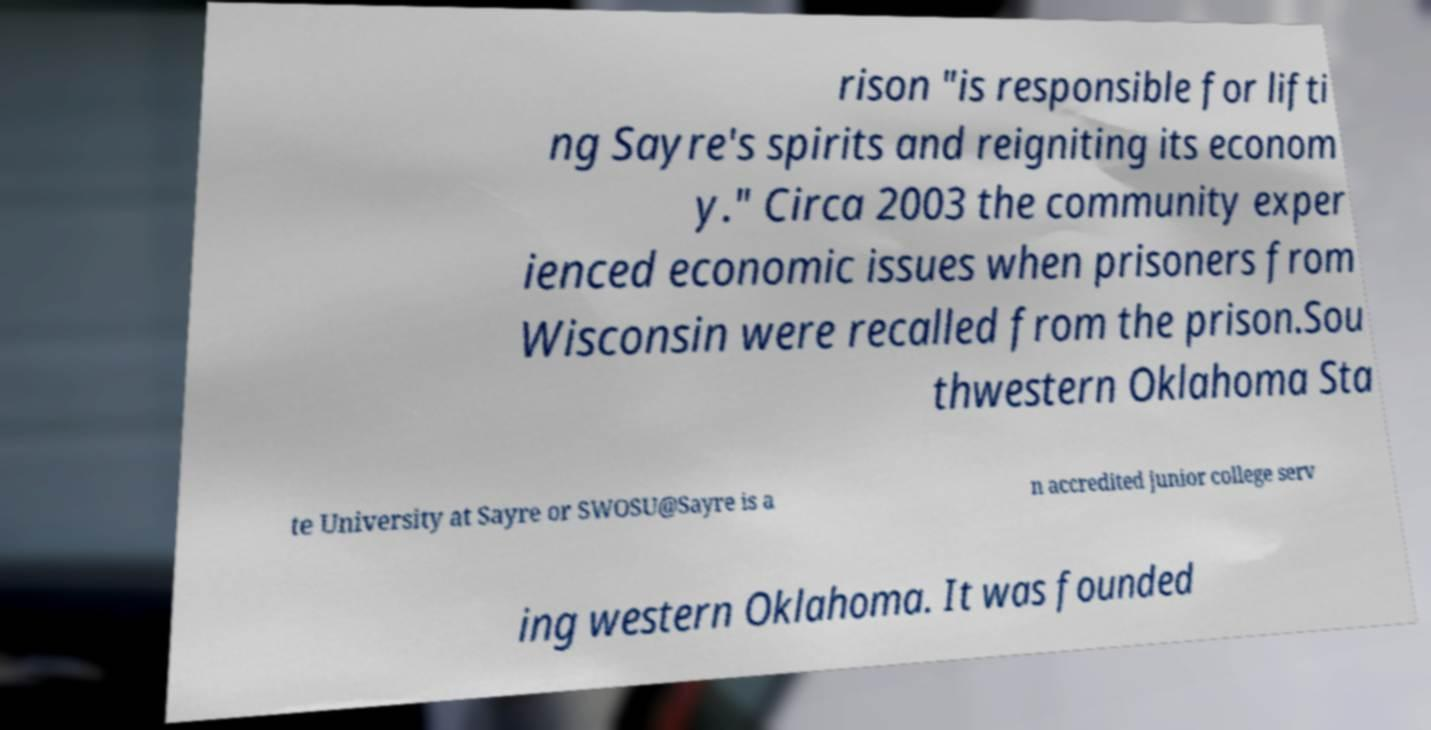Could you assist in decoding the text presented in this image and type it out clearly? rison "is responsible for lifti ng Sayre's spirits and reigniting its econom y." Circa 2003 the community exper ienced economic issues when prisoners from Wisconsin were recalled from the prison.Sou thwestern Oklahoma Sta te University at Sayre or SWOSU@Sayre is a n accredited junior college serv ing western Oklahoma. It was founded 